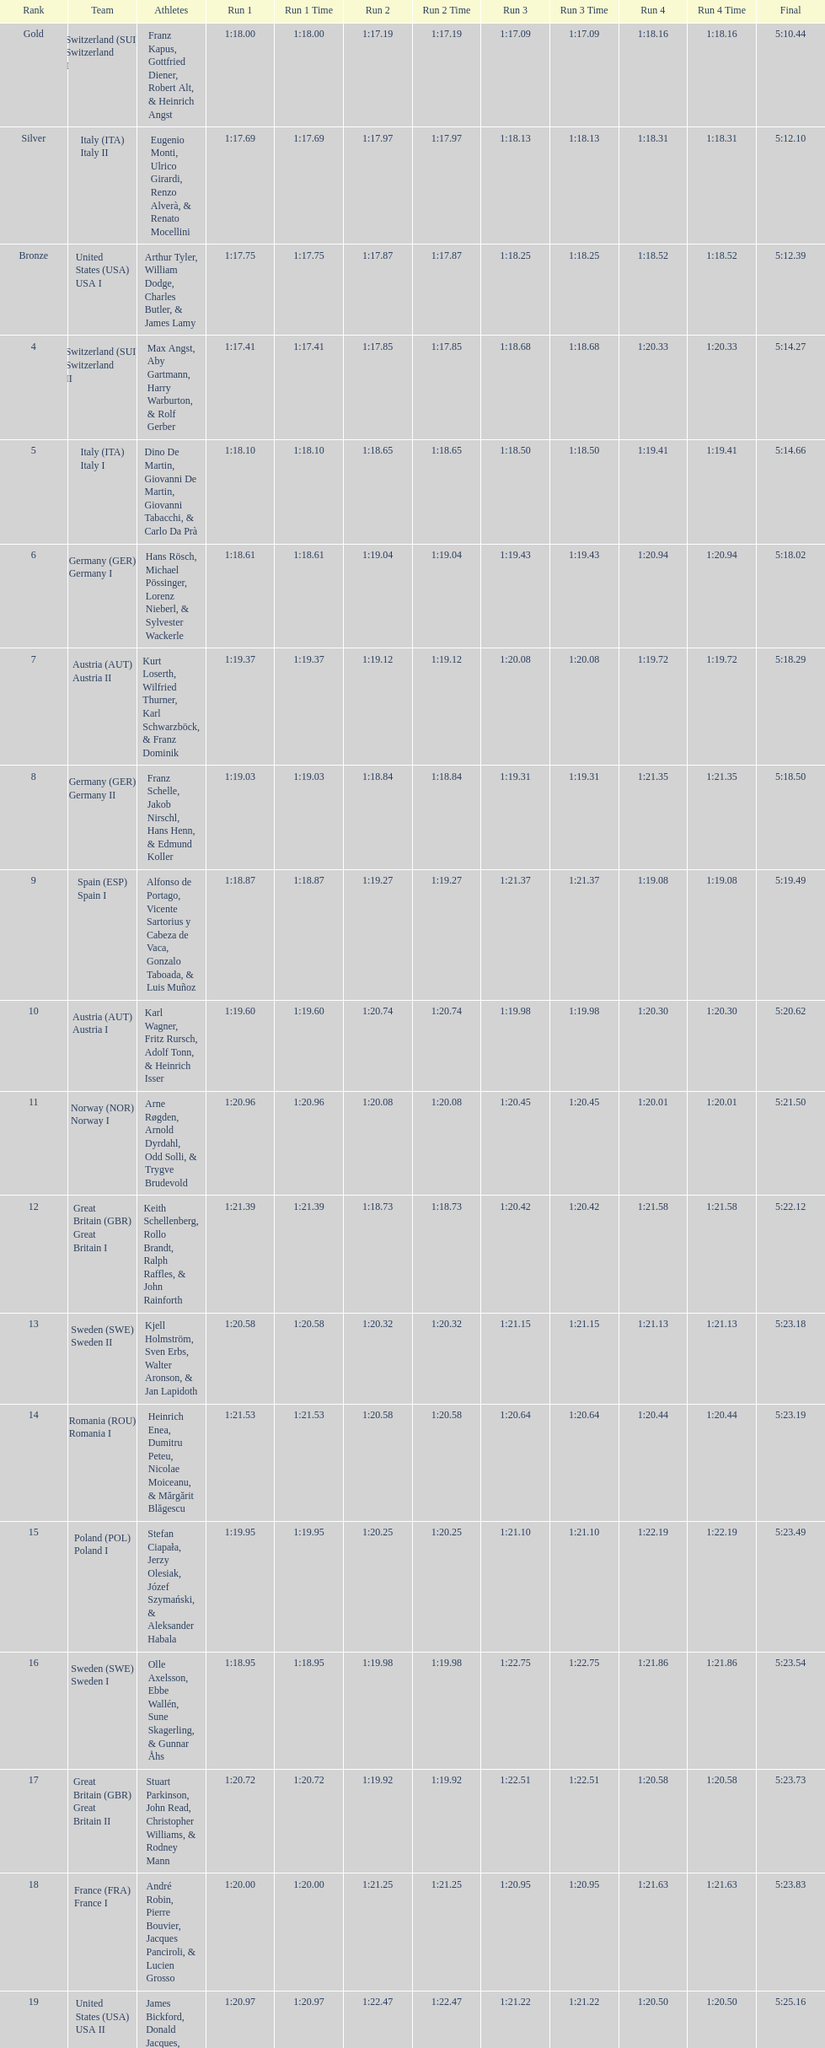What team came in second to last place? Romania. 